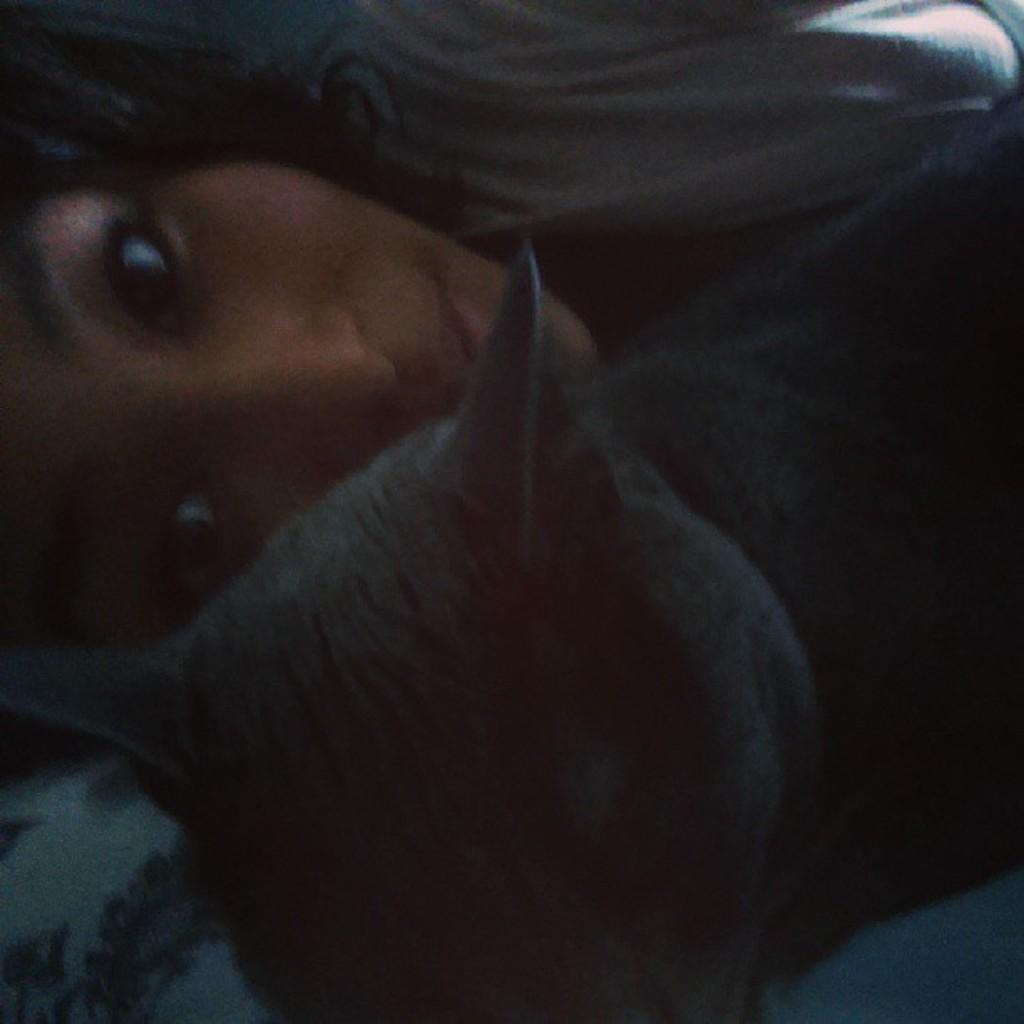Can you describe this image briefly? In this image we can see a girl, beside the girl there is a cat. 